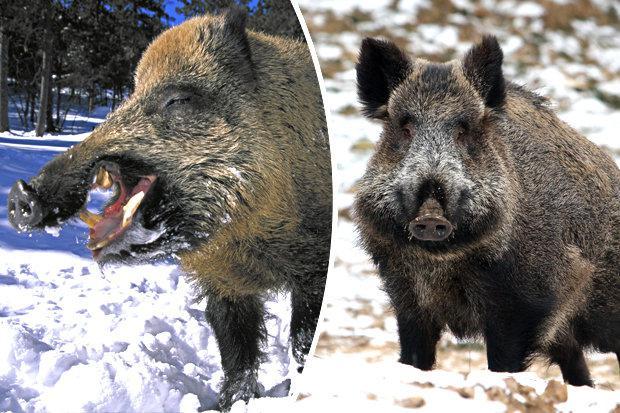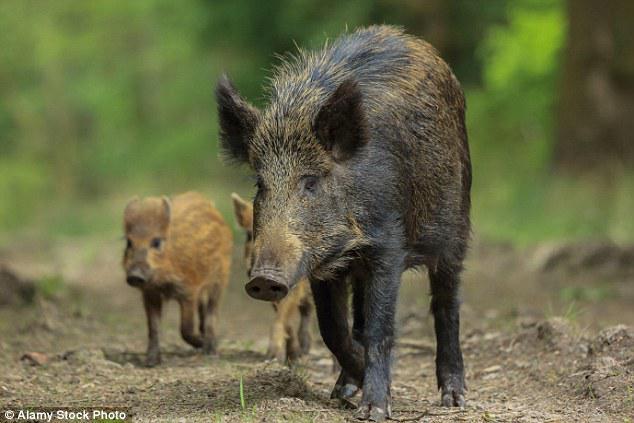The first image is the image on the left, the second image is the image on the right. Given the left and right images, does the statement "In one image, a boar is standing in snow." hold true? Answer yes or no. Yes. The first image is the image on the left, the second image is the image on the right. Examine the images to the left and right. Is the description "One image contains only baby piglets with distinctive brown and beige striped fur, standing on ground with bright green grass." accurate? Answer yes or no. No. 